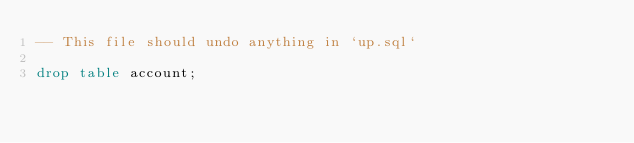Convert code to text. <code><loc_0><loc_0><loc_500><loc_500><_SQL_>-- This file should undo anything in `up.sql`

drop table account;</code> 